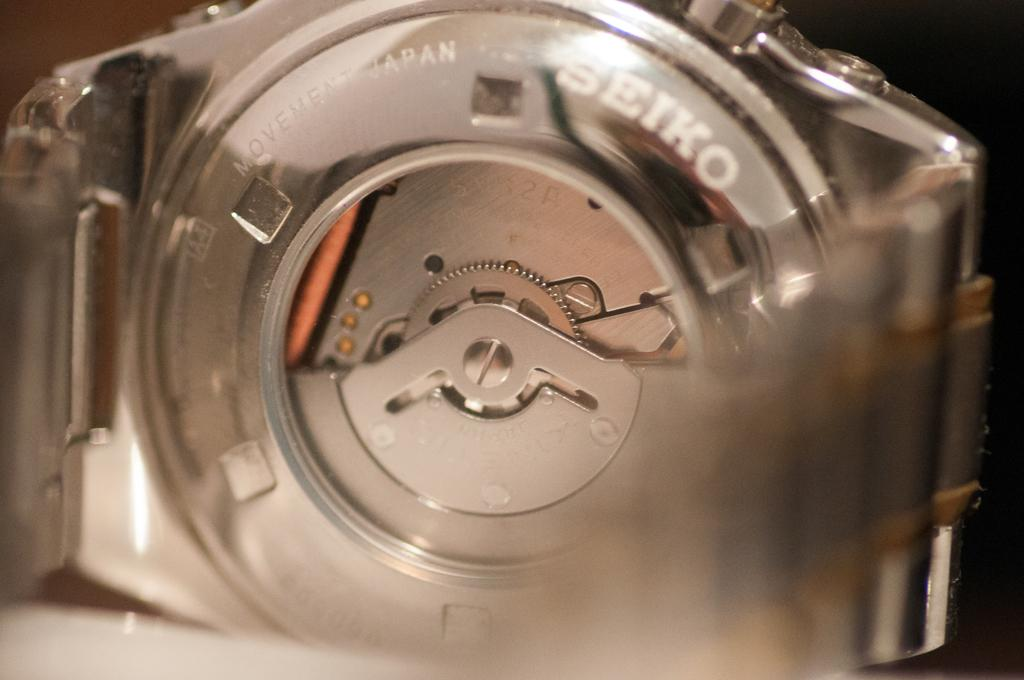<image>
Provide a brief description of the given image. A gear mechanism that is made by the Japanese brand Seiko. 